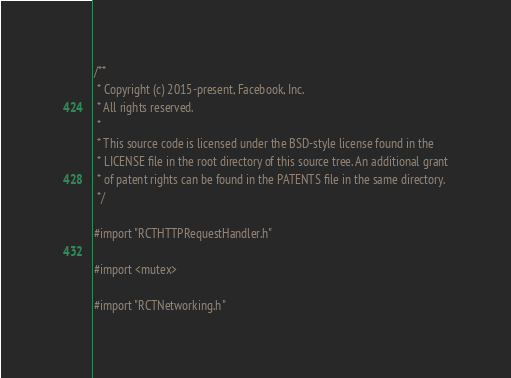Convert code to text. <code><loc_0><loc_0><loc_500><loc_500><_ObjectiveC_>/**
 * Copyright (c) 2015-present, Facebook, Inc.
 * All rights reserved.
 *
 * This source code is licensed under the BSD-style license found in the
 * LICENSE file in the root directory of this source tree. An additional grant
 * of patent rights can be found in the PATENTS file in the same directory.
 */

#import "RCTHTTPRequestHandler.h"

#import <mutex>

#import "RCTNetworking.h"
</code> 